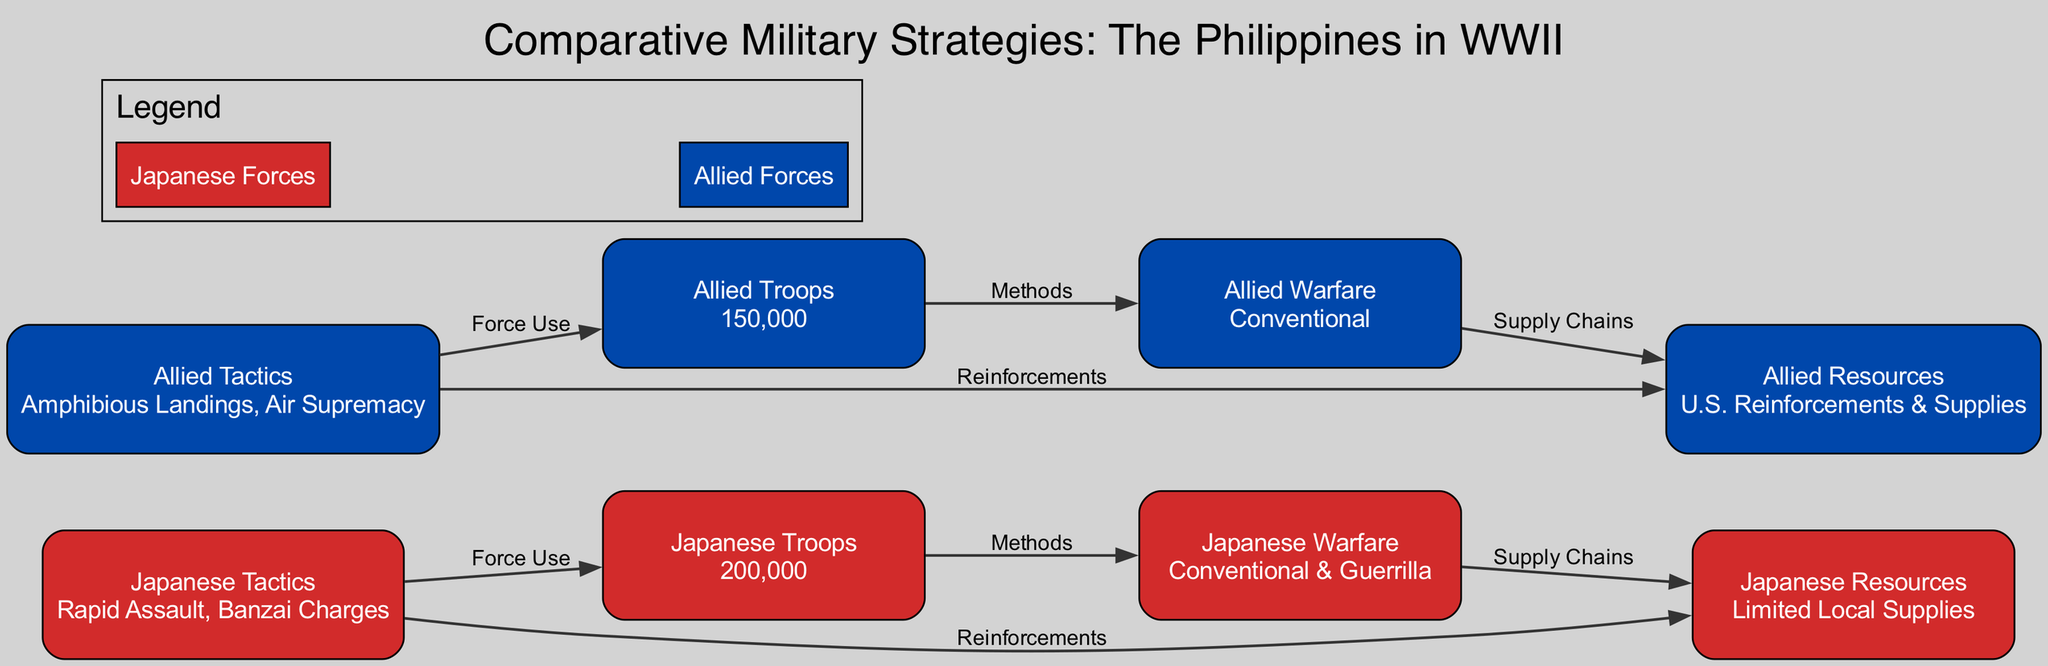What is the number of Japanese troops? The node for Japanese Troops shows the value "200,000", which clearly states the number of troops on the Japanese side.
Answer: 200,000 What type of warfare did the Allies employ? The node labeled "Allied Warfare" indicates that the type of warfare used by Allied troops is "Conventional".
Answer: Conventional What resources did the Japanese have? The node labeled "Japanese Resources" states "Limited Local Supplies", which indicates the resource situation for the Japanese forces.
Answer: Limited Local Supplies Which tactical decision was used by the Allies? The "Allied Tactics" node lists "Amphibious Landings, Air Supremacy", showing the specific tactical decisions made by the Allied forces.
Answer: Amphibious Landings, Air Supremacy How many edges connect Japanese tactics to Japanese resources? Upon examining the diagram, there is one directed edge connecting "Japanese Tactics" to "Japanese Resources", indicating a single relationship.
Answer: 1 Which force had more troops and how many more? The diagram shows "Japanese Troops" with 200,000 and "Allied Troops" with 150,000. The difference can be calculated as 200,000 - 150,000, which results in 50,000 more Japanese troops.
Answer: 50,000 What is the connection between Allied warfare and resources? The edge labeled "Supply Chains" directly links "Allied Warfare" to "Allied Resources", indicating the relationship that connects the methods and available supplies of the Allies.
Answer: Supply Chains What was the primary tactic involving Japanese troops? The node "Japanese Tactics" lists "Rapid Assault, Banzai Charges", which indicates the main tactical approach used specifically for their troops.
Answer: Rapid Assault, Banzai Charges What color represents the Allied Forces in this diagram? In the diagram, the Allied Forces are represented in blue, indicated by the specified color code for nodes associated with Allied elements.
Answer: Blue 